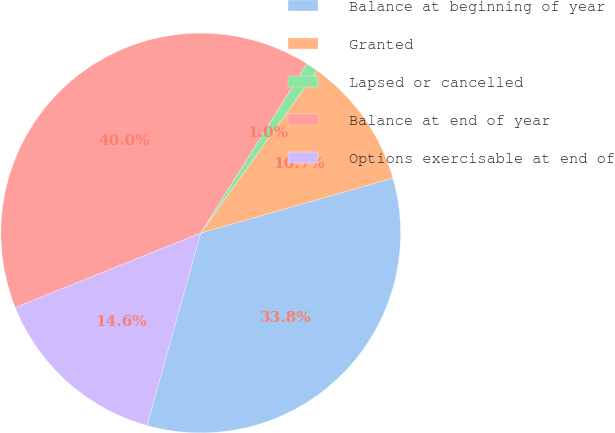Convert chart to OTSL. <chart><loc_0><loc_0><loc_500><loc_500><pie_chart><fcel>Balance at beginning of year<fcel>Granted<fcel>Lapsed or cancelled<fcel>Balance at end of year<fcel>Options exercisable at end of<nl><fcel>33.77%<fcel>10.68%<fcel>0.97%<fcel>40.0%<fcel>14.58%<nl></chart> 